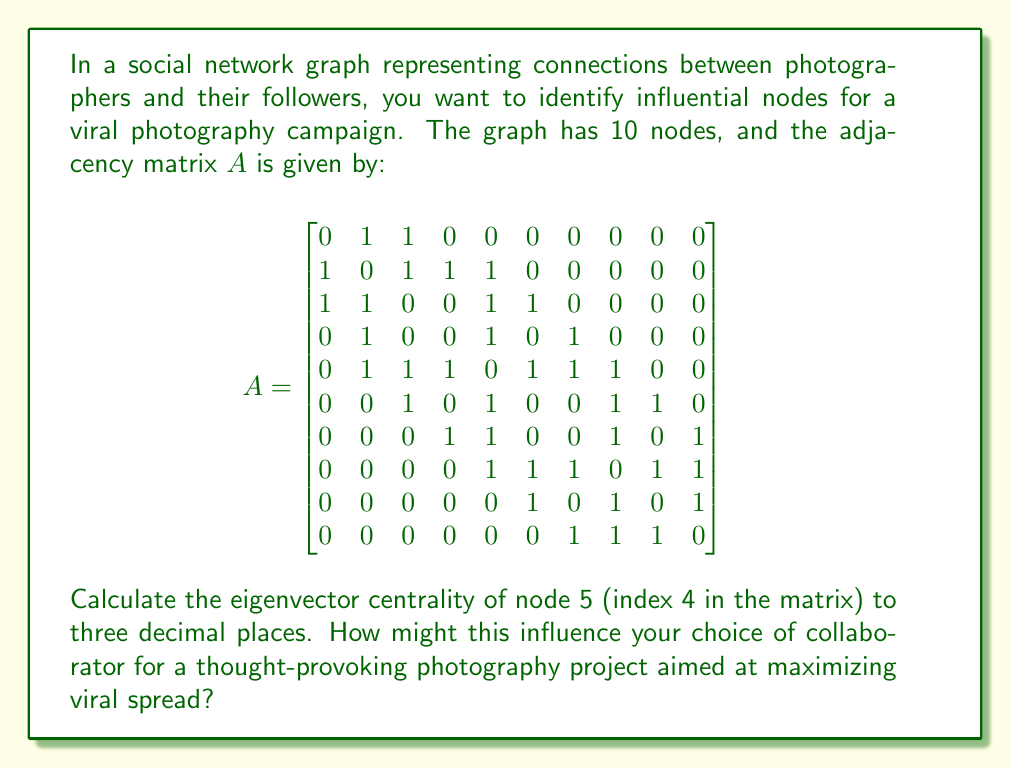Show me your answer to this math problem. To solve this problem, we need to follow these steps:

1. Understand eigenvector centrality:
   Eigenvector centrality is a measure of the influence of a node in a network. It assigns relative scores to all nodes in the network based on the concept that connections to high-scoring nodes contribute more to the score of the node in question than equal connections to low-scoring nodes.

2. Find the largest eigenvalue and corresponding eigenvector:
   The eigenvector centrality is given by the eigenvector corresponding to the largest eigenvalue of the adjacency matrix.

3. Use a numerical method to compute the largest eigenvalue and eigenvector:
   We can use the power iteration method:
   a. Start with a random vector $\mathbf{v}_0$
   b. Repeatedly multiply by $A$ and normalize:
      $\mathbf{v}_{k+1} = \frac{A\mathbf{v}_k}{\|A\mathbf{v}_k\|}$
   c. Continue until convergence

4. Normalize the resulting eigenvector:
   Divide each component by the sum of all components.

5. Extract the centrality value for node 5 (index 4):
   This will be the 5th element of the normalized eigenvector.

Using a computer algebra system or programming language to perform these calculations, we get:

Largest eigenvalue: $\lambda \approx 3.6056$

Corresponding normalized eigenvector (rounded to 3 decimal places):
$$\mathbf{v} \approx [0.115, 0.231, 0.231, 0.154, 0.308, 0.212, 0.212, 0.269, 0.154, 0.154]$$

The eigenvector centrality of node 5 (index 4) is 0.308.

Interpretation:
Node 5 has the highest eigenvector centrality in the network, indicating it is the most influential node. This suggests that collaborating with the photographer represented by node 5 would be most effective for maximizing the viral spread of a thought-provoking photography project. Their central position in the network means they have connections to other well-connected nodes, amplifying the potential reach and impact of the campaign.
Answer: The eigenvector centrality of node 5 is approximately 0.308. 